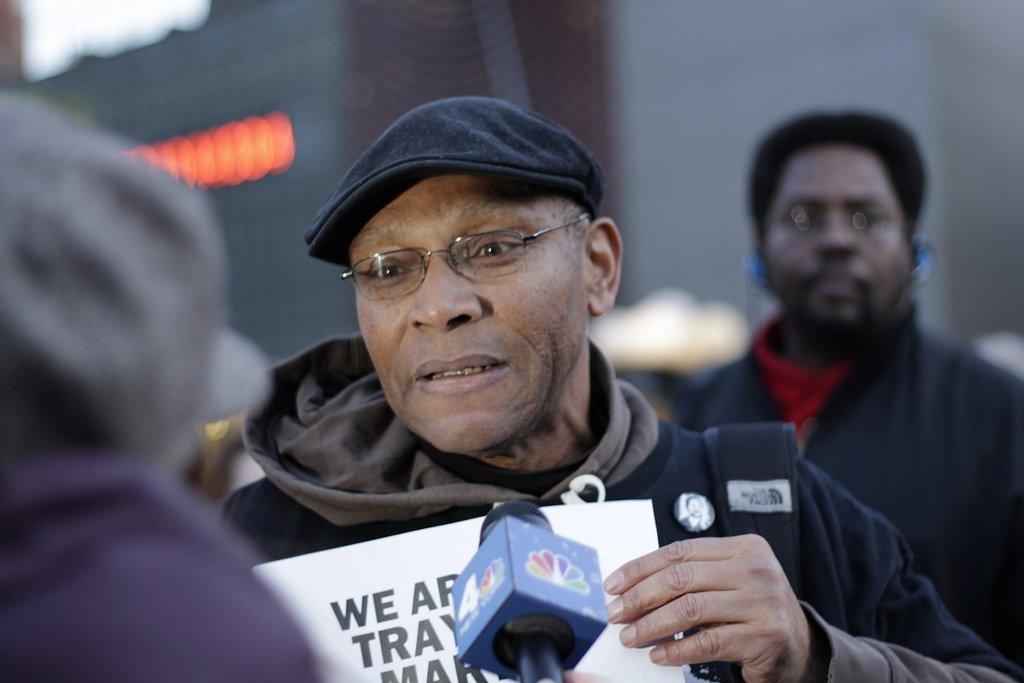How would you summarize this image in a sentence or two? This picture seems to be clicked outside. In the center we can see the group of persons standing and we can see a microphone and the text on the paper. The background of the image is blurry and we can see the lights in the background. 